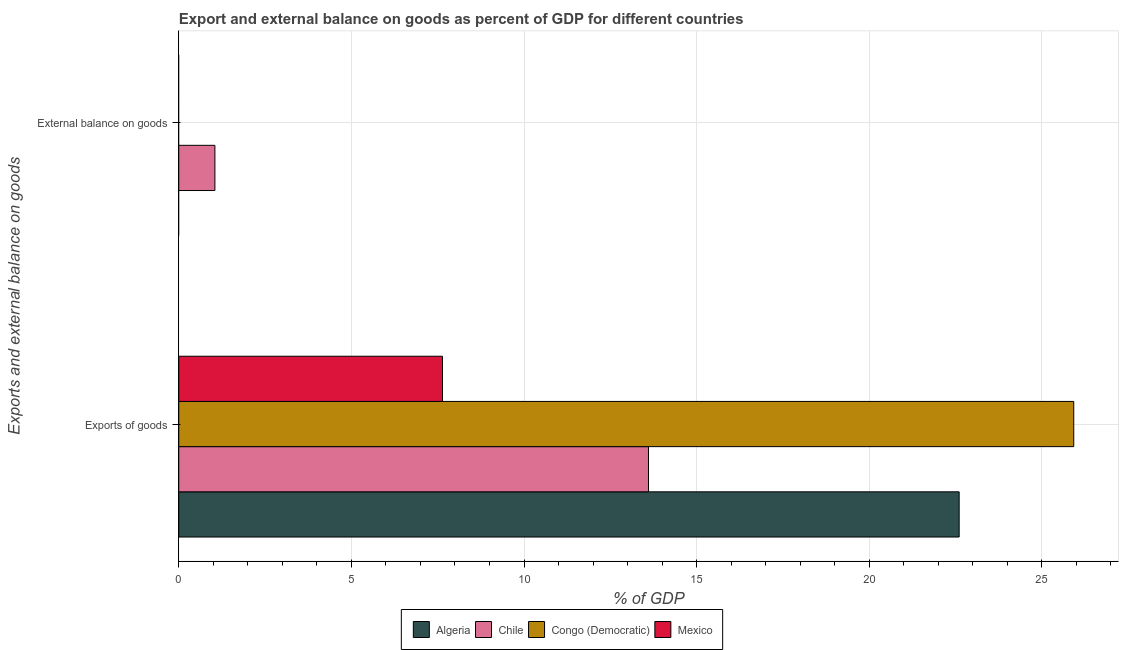How many different coloured bars are there?
Offer a terse response. 4. Are the number of bars per tick equal to the number of legend labels?
Offer a terse response. No. What is the label of the 2nd group of bars from the top?
Give a very brief answer. Exports of goods. What is the export of goods as percentage of gdp in Congo (Democratic)?
Provide a succinct answer. 25.92. Across all countries, what is the maximum external balance on goods as percentage of gdp?
Make the answer very short. 1.05. Across all countries, what is the minimum export of goods as percentage of gdp?
Your answer should be compact. 7.64. What is the total export of goods as percentage of gdp in the graph?
Ensure brevity in your answer.  69.77. What is the difference between the export of goods as percentage of gdp in Mexico and that in Algeria?
Your answer should be compact. -14.97. What is the difference between the external balance on goods as percentage of gdp in Mexico and the export of goods as percentage of gdp in Algeria?
Your answer should be compact. -22.6. What is the average external balance on goods as percentage of gdp per country?
Offer a very short reply. 0.26. What is the difference between the export of goods as percentage of gdp and external balance on goods as percentage of gdp in Chile?
Make the answer very short. 12.56. In how many countries, is the external balance on goods as percentage of gdp greater than 7 %?
Provide a succinct answer. 0. What is the ratio of the export of goods as percentage of gdp in Algeria to that in Chile?
Ensure brevity in your answer.  1.66. Are all the bars in the graph horizontal?
Your response must be concise. Yes. Does the graph contain any zero values?
Ensure brevity in your answer.  Yes. Where does the legend appear in the graph?
Ensure brevity in your answer.  Bottom center. How many legend labels are there?
Offer a terse response. 4. What is the title of the graph?
Provide a succinct answer. Export and external balance on goods as percent of GDP for different countries. Does "Qatar" appear as one of the legend labels in the graph?
Make the answer very short. No. What is the label or title of the X-axis?
Your answer should be very brief. % of GDP. What is the label or title of the Y-axis?
Make the answer very short. Exports and external balance on goods. What is the % of GDP of Algeria in Exports of goods?
Offer a terse response. 22.6. What is the % of GDP in Chile in Exports of goods?
Make the answer very short. 13.61. What is the % of GDP of Congo (Democratic) in Exports of goods?
Provide a succinct answer. 25.92. What is the % of GDP in Mexico in Exports of goods?
Give a very brief answer. 7.64. What is the % of GDP in Algeria in External balance on goods?
Your response must be concise. 0. What is the % of GDP in Chile in External balance on goods?
Your answer should be compact. 1.05. What is the % of GDP of Mexico in External balance on goods?
Make the answer very short. 0. Across all Exports and external balance on goods, what is the maximum % of GDP of Algeria?
Your response must be concise. 22.6. Across all Exports and external balance on goods, what is the maximum % of GDP of Chile?
Ensure brevity in your answer.  13.61. Across all Exports and external balance on goods, what is the maximum % of GDP in Congo (Democratic)?
Offer a very short reply. 25.92. Across all Exports and external balance on goods, what is the maximum % of GDP of Mexico?
Ensure brevity in your answer.  7.64. Across all Exports and external balance on goods, what is the minimum % of GDP of Algeria?
Your answer should be very brief. 0. Across all Exports and external balance on goods, what is the minimum % of GDP of Chile?
Your response must be concise. 1.05. Across all Exports and external balance on goods, what is the minimum % of GDP in Mexico?
Offer a terse response. 0. What is the total % of GDP of Algeria in the graph?
Give a very brief answer. 22.6. What is the total % of GDP in Chile in the graph?
Your response must be concise. 14.65. What is the total % of GDP of Congo (Democratic) in the graph?
Offer a terse response. 25.92. What is the total % of GDP of Mexico in the graph?
Offer a terse response. 7.64. What is the difference between the % of GDP in Chile in Exports of goods and that in External balance on goods?
Provide a short and direct response. 12.56. What is the difference between the % of GDP in Algeria in Exports of goods and the % of GDP in Chile in External balance on goods?
Offer a terse response. 21.56. What is the average % of GDP in Algeria per Exports and external balance on goods?
Your response must be concise. 11.3. What is the average % of GDP of Chile per Exports and external balance on goods?
Make the answer very short. 7.33. What is the average % of GDP in Congo (Democratic) per Exports and external balance on goods?
Offer a terse response. 12.96. What is the average % of GDP in Mexico per Exports and external balance on goods?
Provide a succinct answer. 3.82. What is the difference between the % of GDP in Algeria and % of GDP in Chile in Exports of goods?
Provide a short and direct response. 9. What is the difference between the % of GDP of Algeria and % of GDP of Congo (Democratic) in Exports of goods?
Ensure brevity in your answer.  -3.32. What is the difference between the % of GDP in Algeria and % of GDP in Mexico in Exports of goods?
Your answer should be compact. 14.97. What is the difference between the % of GDP in Chile and % of GDP in Congo (Democratic) in Exports of goods?
Your answer should be very brief. -12.32. What is the difference between the % of GDP in Chile and % of GDP in Mexico in Exports of goods?
Make the answer very short. 5.97. What is the difference between the % of GDP in Congo (Democratic) and % of GDP in Mexico in Exports of goods?
Make the answer very short. 18.29. What is the ratio of the % of GDP in Chile in Exports of goods to that in External balance on goods?
Offer a very short reply. 13. What is the difference between the highest and the second highest % of GDP in Chile?
Ensure brevity in your answer.  12.56. What is the difference between the highest and the lowest % of GDP in Algeria?
Give a very brief answer. 22.6. What is the difference between the highest and the lowest % of GDP in Chile?
Make the answer very short. 12.56. What is the difference between the highest and the lowest % of GDP of Congo (Democratic)?
Provide a short and direct response. 25.92. What is the difference between the highest and the lowest % of GDP in Mexico?
Your response must be concise. 7.64. 